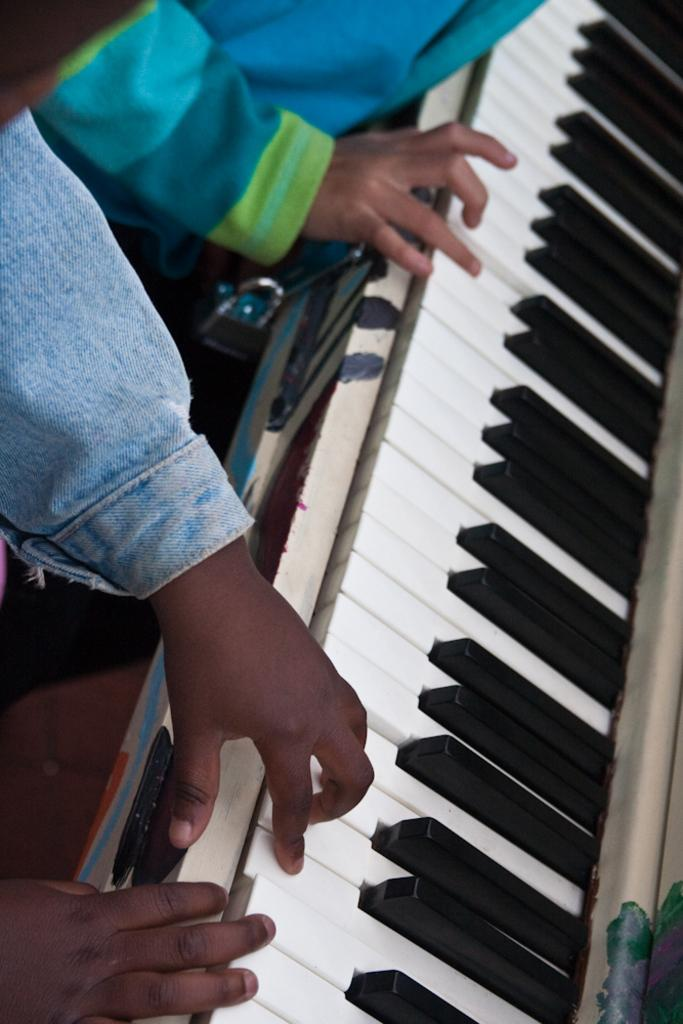What is the main activity being performed in the image? There is a person playing the piano in the image. What can be observed about the piano itself? The piano has black and white keys. What type of powder is being sprinkled on the piano keys in the image? There is no powder present in the image; the piano keys are simply black and white. 